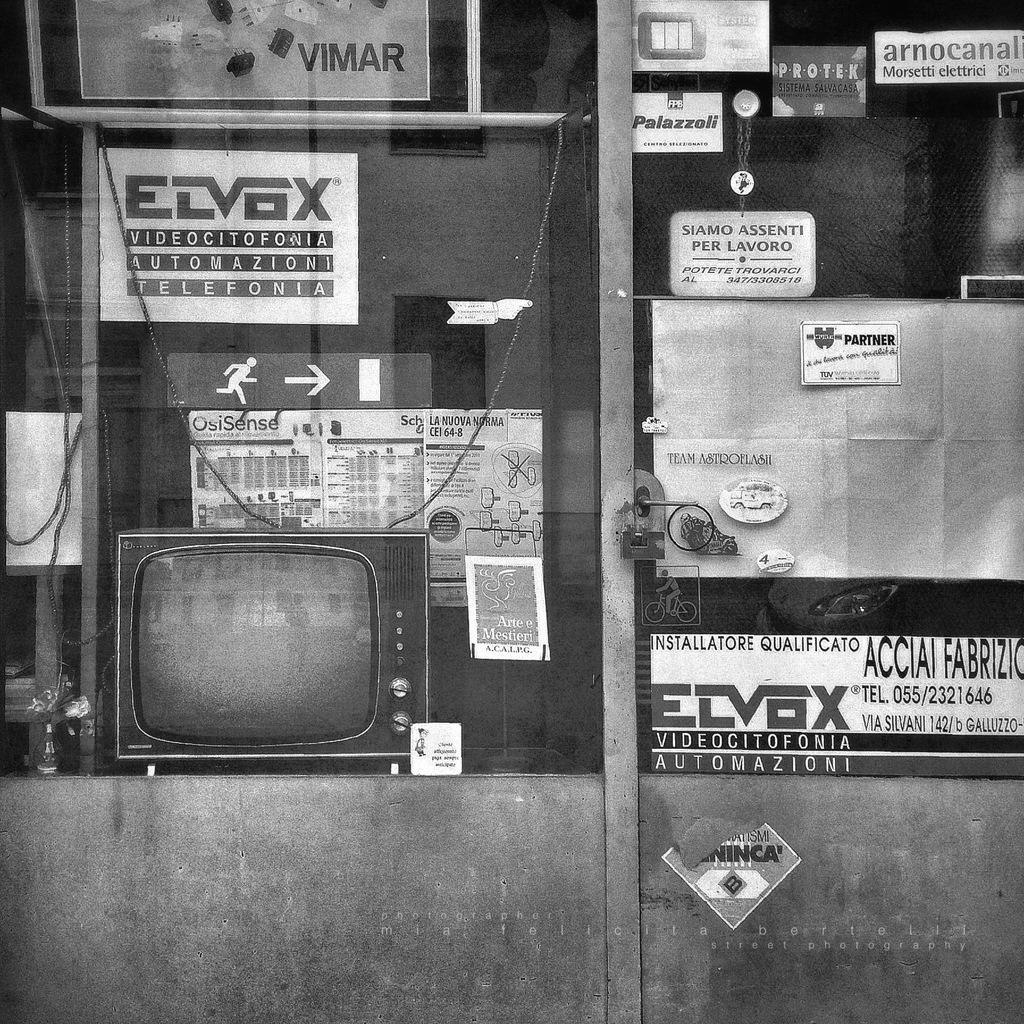<image>
Give a short and clear explanation of the subsequent image. A grimy store window displays products from the Elvox company. 